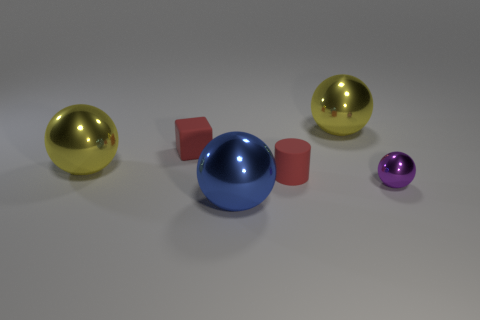Are the tiny ball and the block made of the same material?
Offer a very short reply. No. There is a red rubber object that is in front of the yellow thing left of the big yellow ball that is behind the rubber block; what size is it?
Your answer should be very brief. Small. How many other objects are there of the same color as the matte cylinder?
Your answer should be compact. 1. There is a red matte thing that is the same size as the red rubber cube; what shape is it?
Give a very brief answer. Cylinder. What number of tiny objects are red rubber spheres or blocks?
Your response must be concise. 1. There is a small red rubber object to the left of the large shiny thing in front of the cylinder; are there any big yellow objects that are in front of it?
Your answer should be very brief. Yes. Are there any purple metallic balls that have the same size as the red rubber block?
Give a very brief answer. Yes. There is a purple sphere that is the same size as the red rubber cylinder; what is its material?
Your answer should be compact. Metal. There is a purple ball; is its size the same as the metallic ball in front of the small purple object?
Your answer should be very brief. No. How many rubber objects are either yellow objects or red cylinders?
Your answer should be compact. 1. 